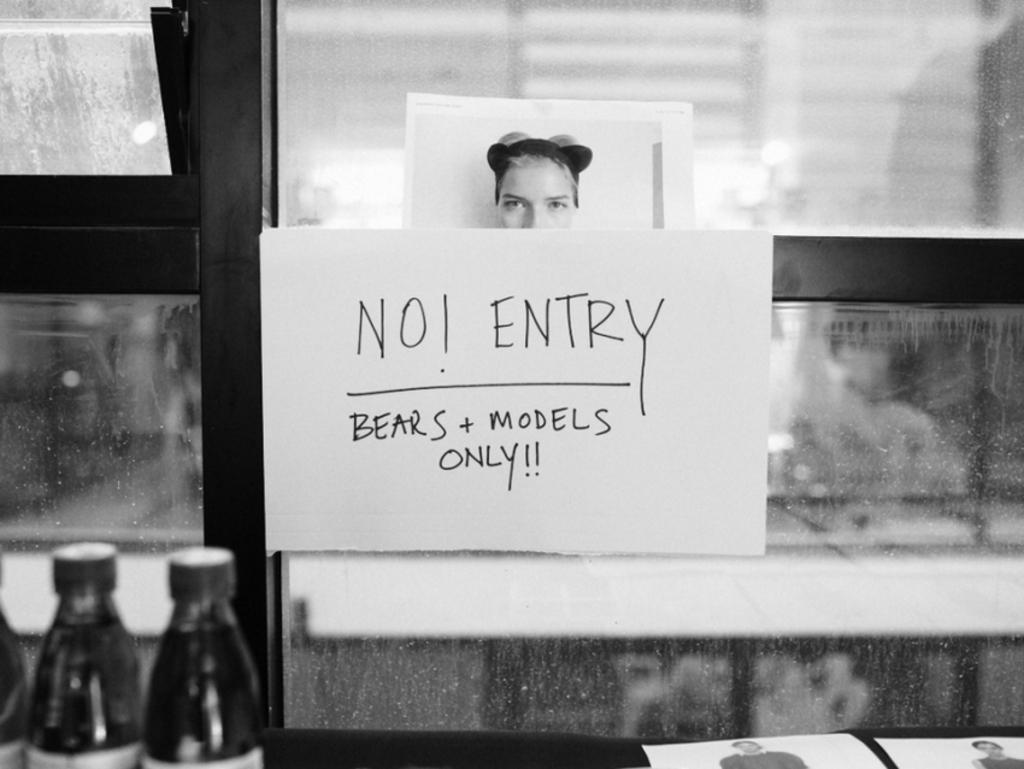What is the main object in the image? There is a board in the image. What can be seen in the background of the image? There are bottles and a window visible in the background of the image. Who is the servant in the image? There is no servant present in the image. What type of camera is being used to take the picture? There is no camera visible in the image, as it is a still image and not a photograph being taken. 